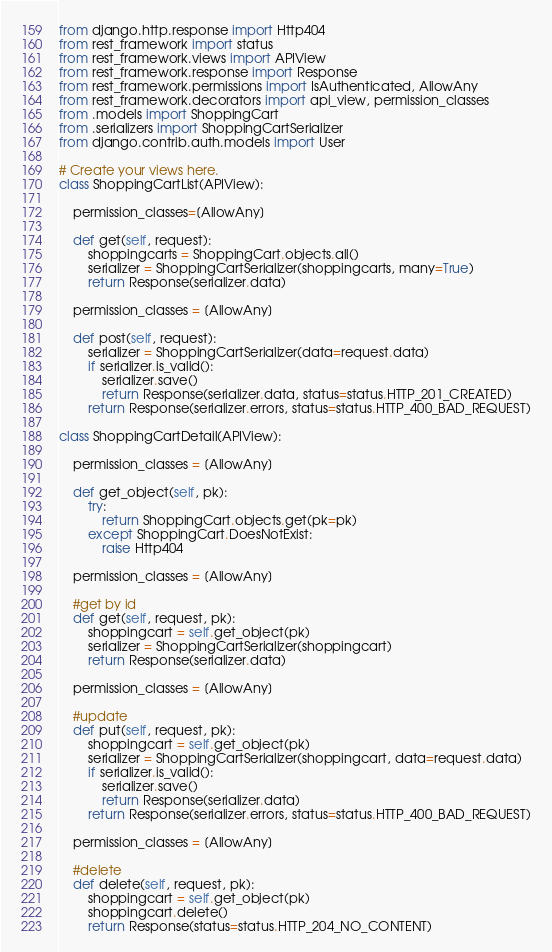Convert code to text. <code><loc_0><loc_0><loc_500><loc_500><_Python_>from django.http.response import Http404
from rest_framework import status 
from rest_framework.views import APIView
from rest_framework.response import Response 
from rest_framework.permissions import IsAuthenticated, AllowAny
from rest_framework.decorators import api_view, permission_classes
from .models import ShoppingCart
from .serializers import ShoppingCartSerializer
from django.contrib.auth.models import User

# Create your views here.
class ShoppingCartList(APIView):
    
    permission_classes=[AllowAny]
    
    def get(self, request):
        shoppingcarts = ShoppingCart.objects.all()
        serializer = ShoppingCartSerializer(shoppingcarts, many=True)
        return Response(serializer.data)
    
    permission_classes = [AllowAny]
    
    def post(self, request):
        serializer = ShoppingCartSerializer(data=request.data)
        if serializer.is_valid():
            serializer.save()
            return Response(serializer.data, status=status.HTTP_201_CREATED)
        return Response(serializer.errors, status=status.HTTP_400_BAD_REQUEST)

class ShoppingCartDetail(APIView):
    
    permission_classes = [AllowAny]

    def get_object(self, pk):
        try:
            return ShoppingCart.objects.get(pk=pk)
        except ShoppingCart.DoesNotExist:
            raise Http404
    
    permission_classes = [AllowAny]

    #get by id
    def get(self, request, pk):
        shoppingcart = self.get_object(pk)
        serializer = ShoppingCartSerializer(shoppingcart)
        return Response(serializer.data)
    
    permission_classes = [AllowAny]

    #update
    def put(self, request, pk):
        shoppingcart = self.get_object(pk)
        serializer = ShoppingCartSerializer(shoppingcart, data=request.data)
        if serializer.is_valid():
            serializer.save()
            return Response(serializer.data)
        return Response(serializer.errors, status=status.HTTP_400_BAD_REQUEST)
    
    permission_classes = [AllowAny]

    #delete
    def delete(self, request, pk):
        shoppingcart = self.get_object(pk)
        shoppingcart.delete()
        return Response(status=status.HTTP_204_NO_CONTENT)
</code> 